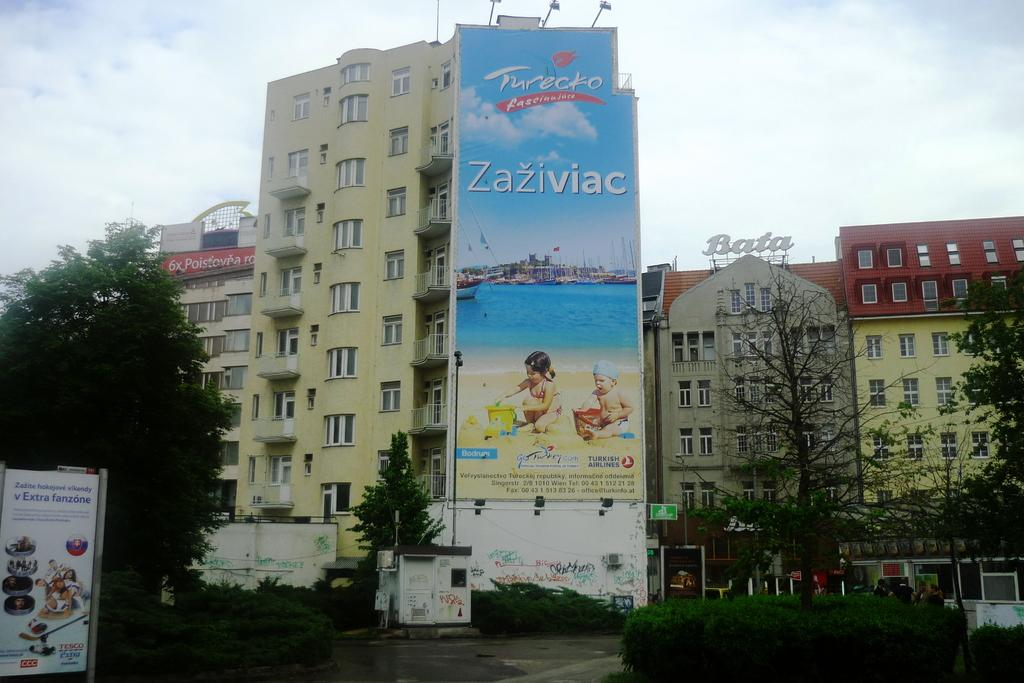<image>
Create a compact narrative representing the image presented. an ad for tureko is shownabove a street 